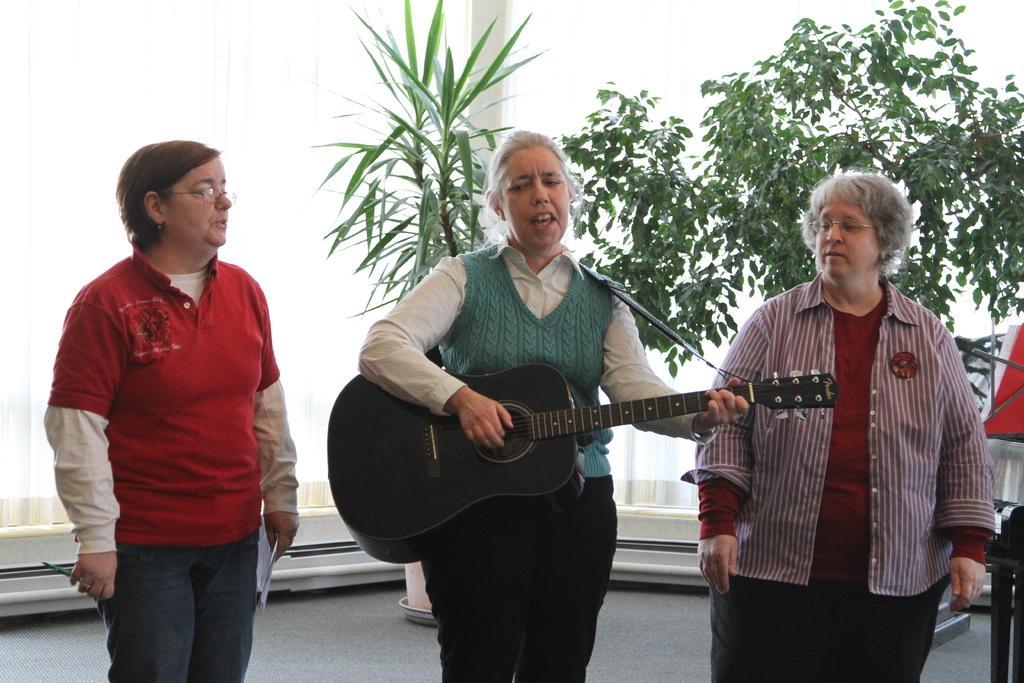In one or two sentences, can you explain what this image depicts? In this image there are group of person standing. Woman in the center standing and holding a musical instrument in her hand is singing as her mouth is open. At the left side women wearing red colour shirt is standing and holding a paper in her hand. In the background there are plants, curtains which is white in colour. 